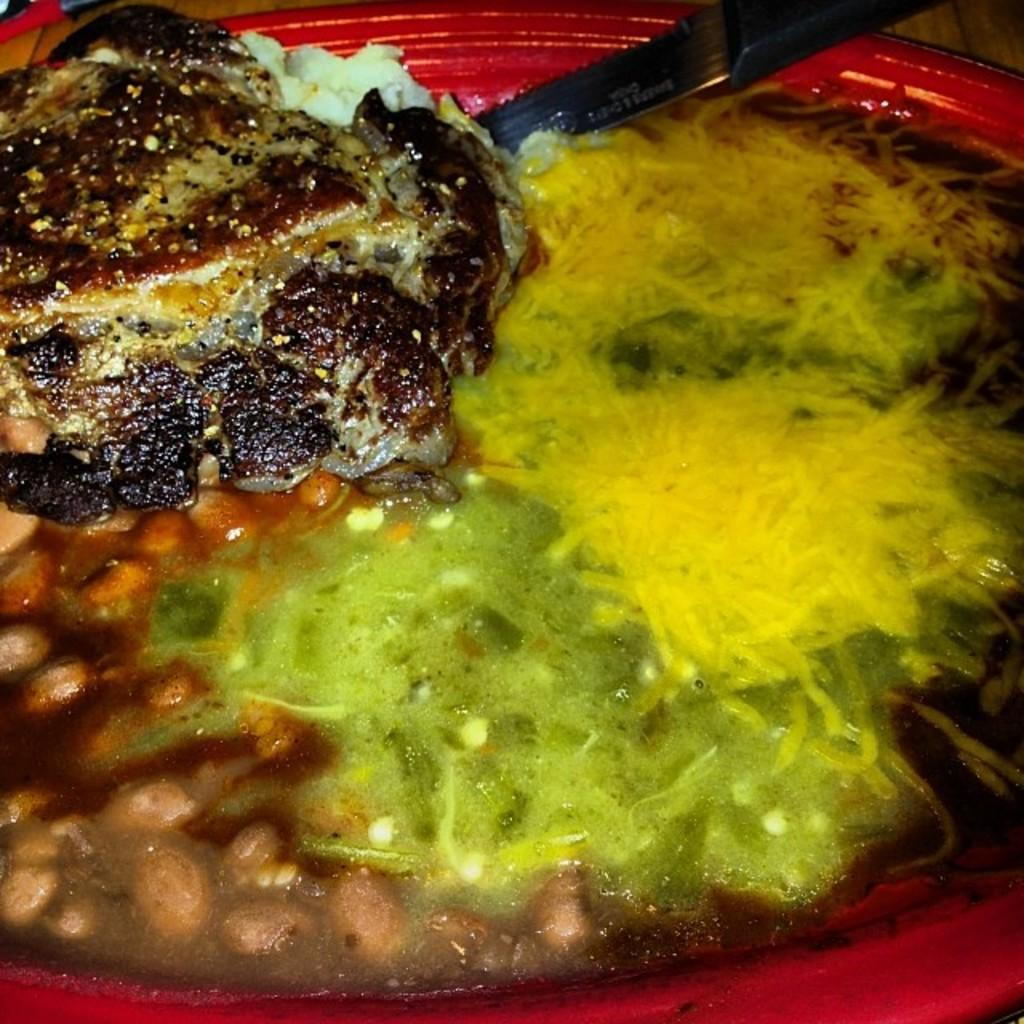What can be seen on the plate in the image? There is a food item and a meat piece on the plate in the image. What is used for cutting the food item on the plate? There is a knife kept in the plate. How many giants are present in the image? There are no giants present in the image. What type of marble is used to make the plate in the image? The image does not provide information about the material used to make the plate. 